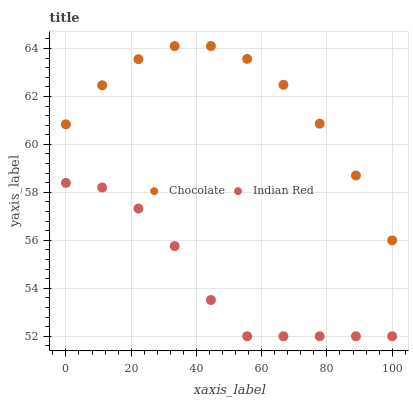Does Indian Red have the minimum area under the curve?
Answer yes or no. Yes. Does Chocolate have the maximum area under the curve?
Answer yes or no. Yes. Does Chocolate have the minimum area under the curve?
Answer yes or no. No. Is Indian Red the smoothest?
Answer yes or no. Yes. Is Chocolate the roughest?
Answer yes or no. Yes. Is Chocolate the smoothest?
Answer yes or no. No. Does Indian Red have the lowest value?
Answer yes or no. Yes. Does Chocolate have the lowest value?
Answer yes or no. No. Does Chocolate have the highest value?
Answer yes or no. Yes. Is Indian Red less than Chocolate?
Answer yes or no. Yes. Is Chocolate greater than Indian Red?
Answer yes or no. Yes. Does Indian Red intersect Chocolate?
Answer yes or no. No. 